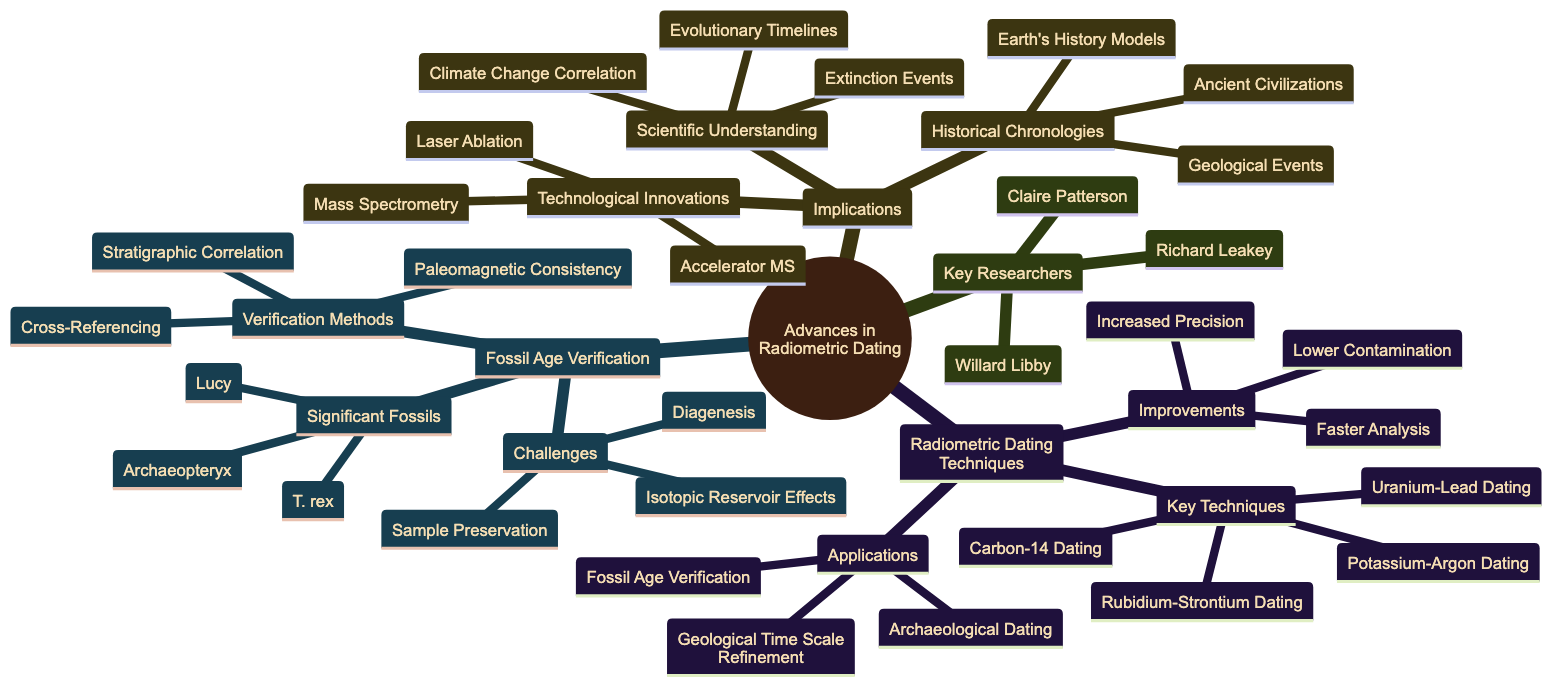What are the key techniques in radiometric dating? The diagram lists "Uranium-Lead Dating," "Potassium-Argon Dating," "Rubidium-Strontium Dating," and "Carbon-14 Dating" as the key techniques related to radiometric dating.
Answer: Uranium-Lead Dating, Potassium-Argon Dating, Rubidium-Strontium Dating, Carbon-14 Dating How many significant fossils are mentioned? The diagram specifies "Archaeopteryx," "Lucy," and "Tyrannosaurus rex" as significant fossils. By counting these entries, we determine that there are three significant fossils noted.
Answer: 3 What is one improvement in radiometric dating techniques? The diagram indicates that one of the improvements in radiometric dating techniques is "Increased Precision." This is clearly listed under the improvements section.
Answer: Increased Precision Which notable figure developed Carbon-14 dating? The diagram highlights "Willard Libby" as the notable figure who developed Carbon-14 dating, thus confirming his role in this specific dating technique's advancement.
Answer: Willard Libby What is one challenge associated with fossil age verification? According to the diagram, "Diagenesis" is listed as one of the challenges related to fossil age verification, indicating it as a significant issue in this context.
Answer: Diagenesis What relationship exists between radiometric dating techniques and applications? The diagram emphasizes that radiometric dating techniques are applied to "Fossil Age Verification," "Geological Time Scale Refinement," and "Archaeological Dating," showcasing their utility and relevance in various fields.
Answer: Fossil Age Verification, Geological Time Scale Refinement, Archaeological Dating Which technological innovation is associated with advances in radiometric dating? The diagram mentions "Mass Spectrometry" as a technological innovation that has implications for advances in radiometric dating, indicating its role in enhancing this method.
Answer: Mass Spectrometry How does radiometric dating improve the understanding of extinction events? The diagram explains that radiometric dating provides better correlation with "Extinction Events" under the implications for scientific understanding, highlighting the contribution to this knowledge area.
Answer: Extinction Events What method is used for verification in fossil age verification? The diagram states "Cross-Referencing with Other Dating Techniques" as a verification method used in fossil age verification, illustrating its importance in the validation process.
Answer: Cross-Referencing with Other Dating Techniques 